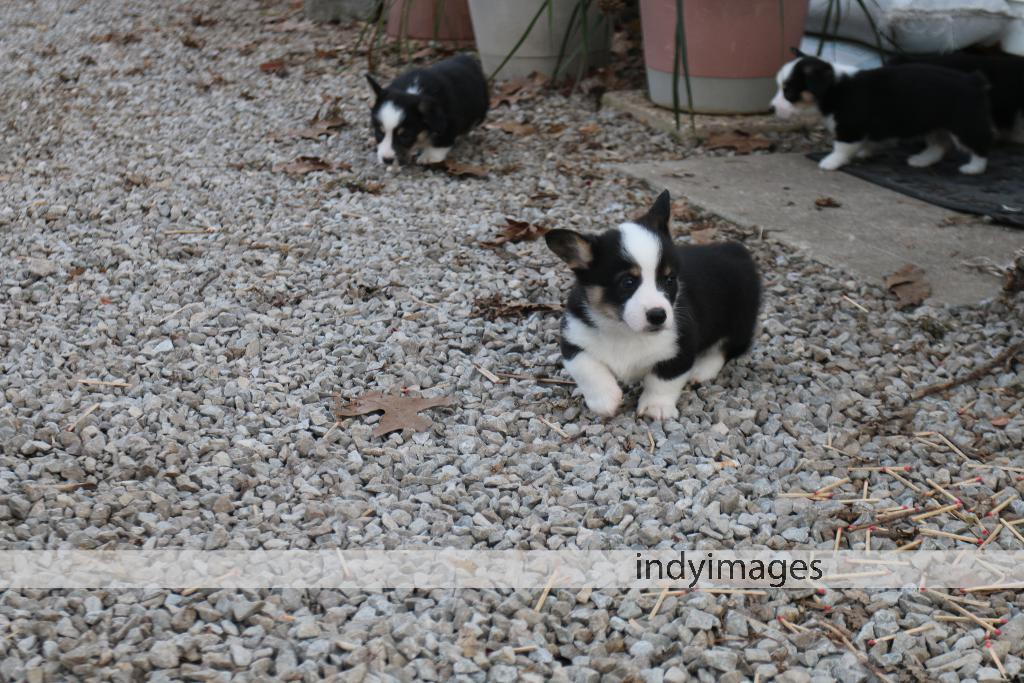What type of animals are in the image? There are black and white puppies in the image. What type of natural elements can be seen in the image? There are stones visible in the image. What man-made objects can be seen in the image? There are matchsticks in the image. Is there any indication of the image's source or ownership? Yes, there is a watermark in the image. Can you see a needle being used by the puppies in the image? No, there is no needle present in the image. Are the puppies engaged in a fight in the image? No, the puppies are not fighting in the image; they appear to be resting or playing. 